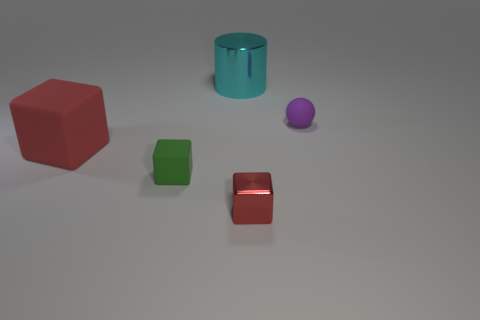Subtract 1 cubes. How many cubes are left? 2 Add 1 cyan metallic cylinders. How many objects exist? 6 Subtract all gray metal objects. Subtract all small purple matte spheres. How many objects are left? 4 Add 2 big red things. How many big red things are left? 3 Add 4 small blocks. How many small blocks exist? 6 Subtract 0 red cylinders. How many objects are left? 5 Subtract all cubes. How many objects are left? 2 